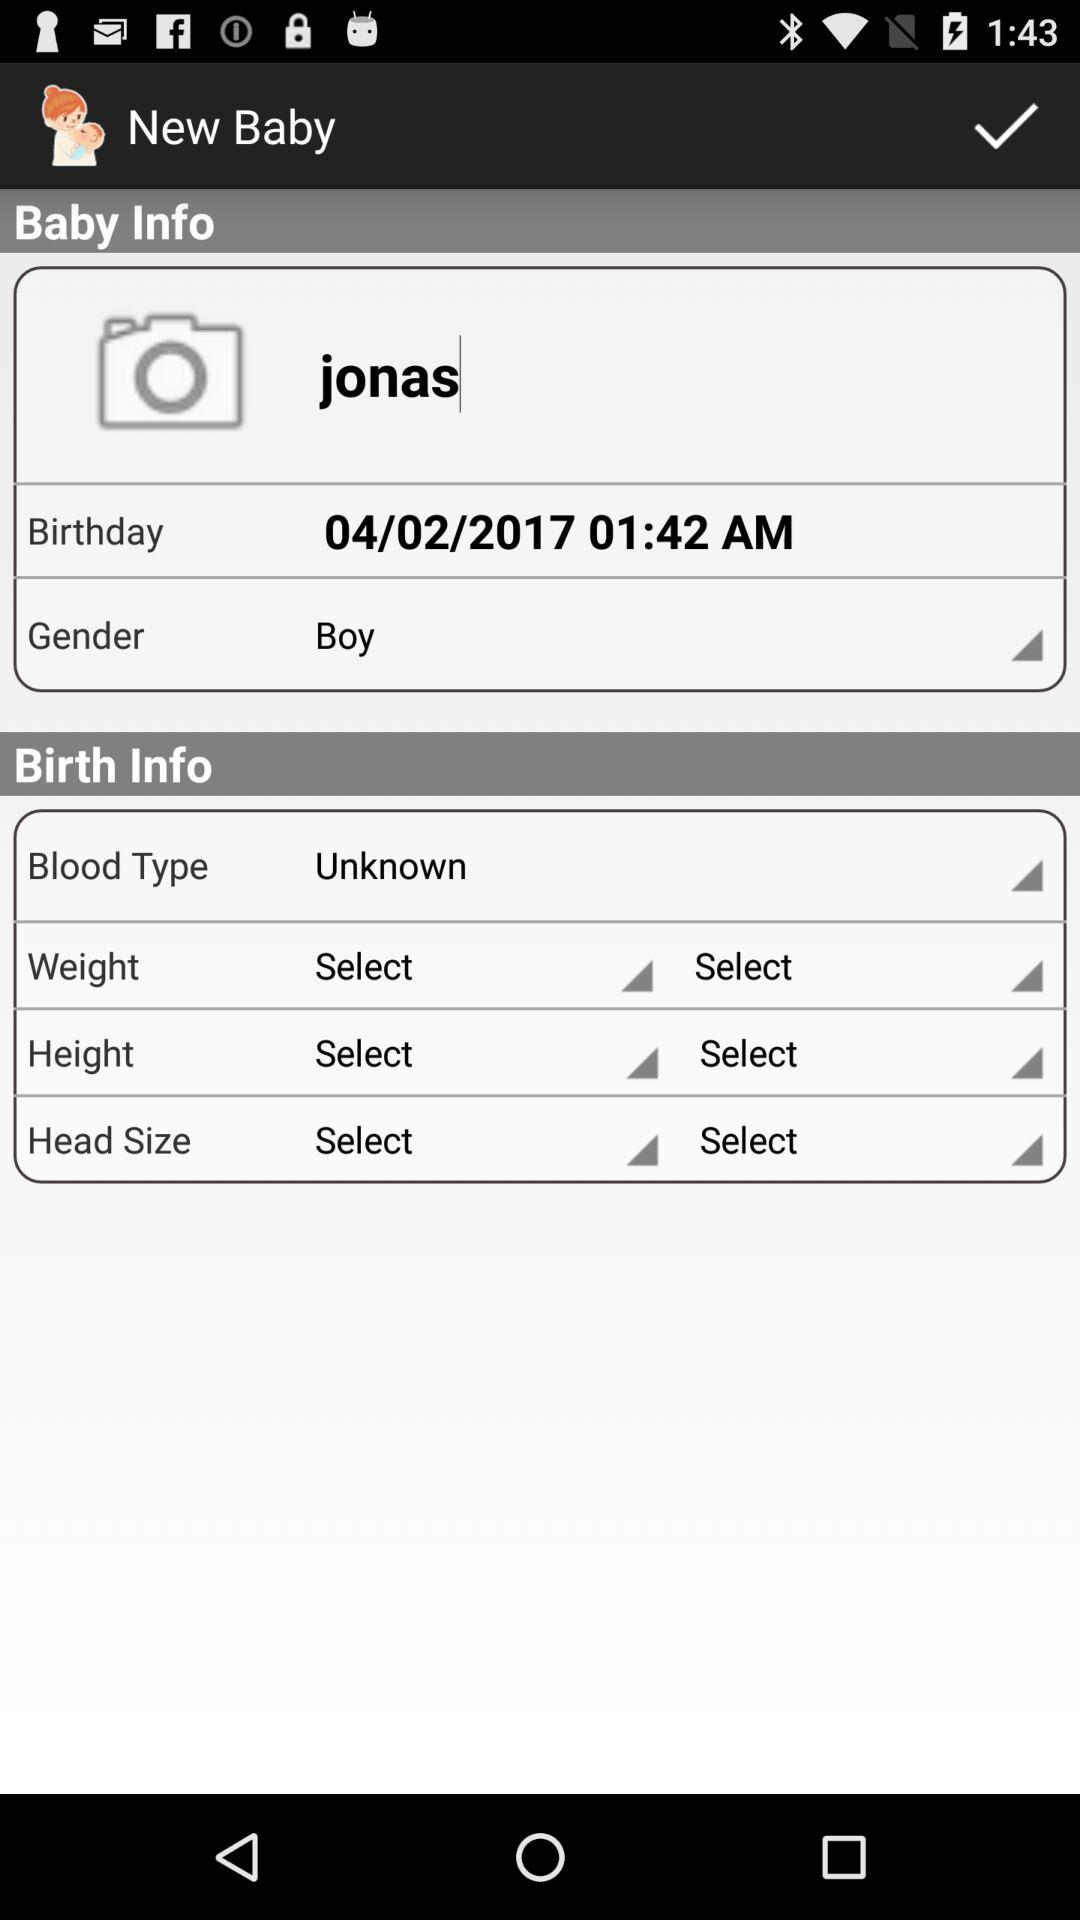What is the name? The name is "jonas". 